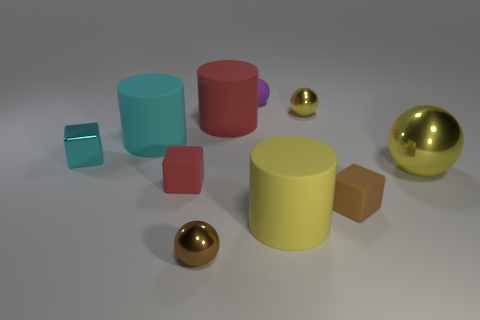Subtract all cubes. How many objects are left? 7 Subtract all cyan cubes. How many cubes are left? 2 Subtract all brown blocks. How many blocks are left? 2 Subtract 0 gray balls. How many objects are left? 10 Subtract 1 cylinders. How many cylinders are left? 2 Subtract all brown spheres. Subtract all purple cubes. How many spheres are left? 3 Subtract all purple balls. How many brown blocks are left? 1 Subtract all small brown blocks. Subtract all yellow rubber cylinders. How many objects are left? 8 Add 1 red rubber cubes. How many red rubber cubes are left? 2 Add 6 brown spheres. How many brown spheres exist? 7 